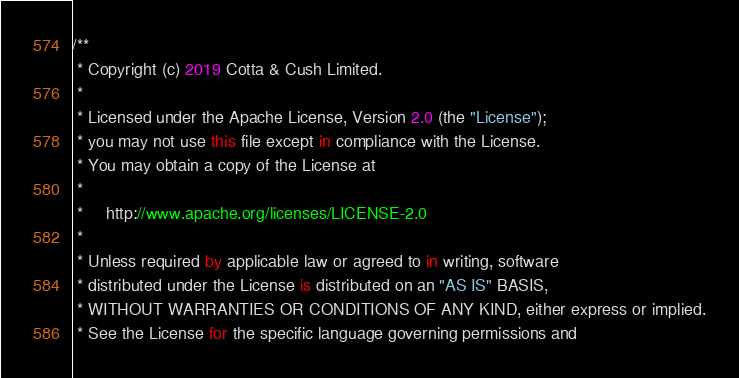Convert code to text. <code><loc_0><loc_0><loc_500><loc_500><_Kotlin_>/**
 * Copyright (c) 2019 Cotta & Cush Limited.
 *
 * Licensed under the Apache License, Version 2.0 (the "License");
 * you may not use this file except in compliance with the License.
 * You may obtain a copy of the License at
 *
 *     http://www.apache.org/licenses/LICENSE-2.0
 *
 * Unless required by applicable law or agreed to in writing, software
 * distributed under the License is distributed on an "AS IS" BASIS,
 * WITHOUT WARRANTIES OR CONDITIONS OF ANY KIND, either express or implied.
 * See the License for the specific language governing permissions and</code> 